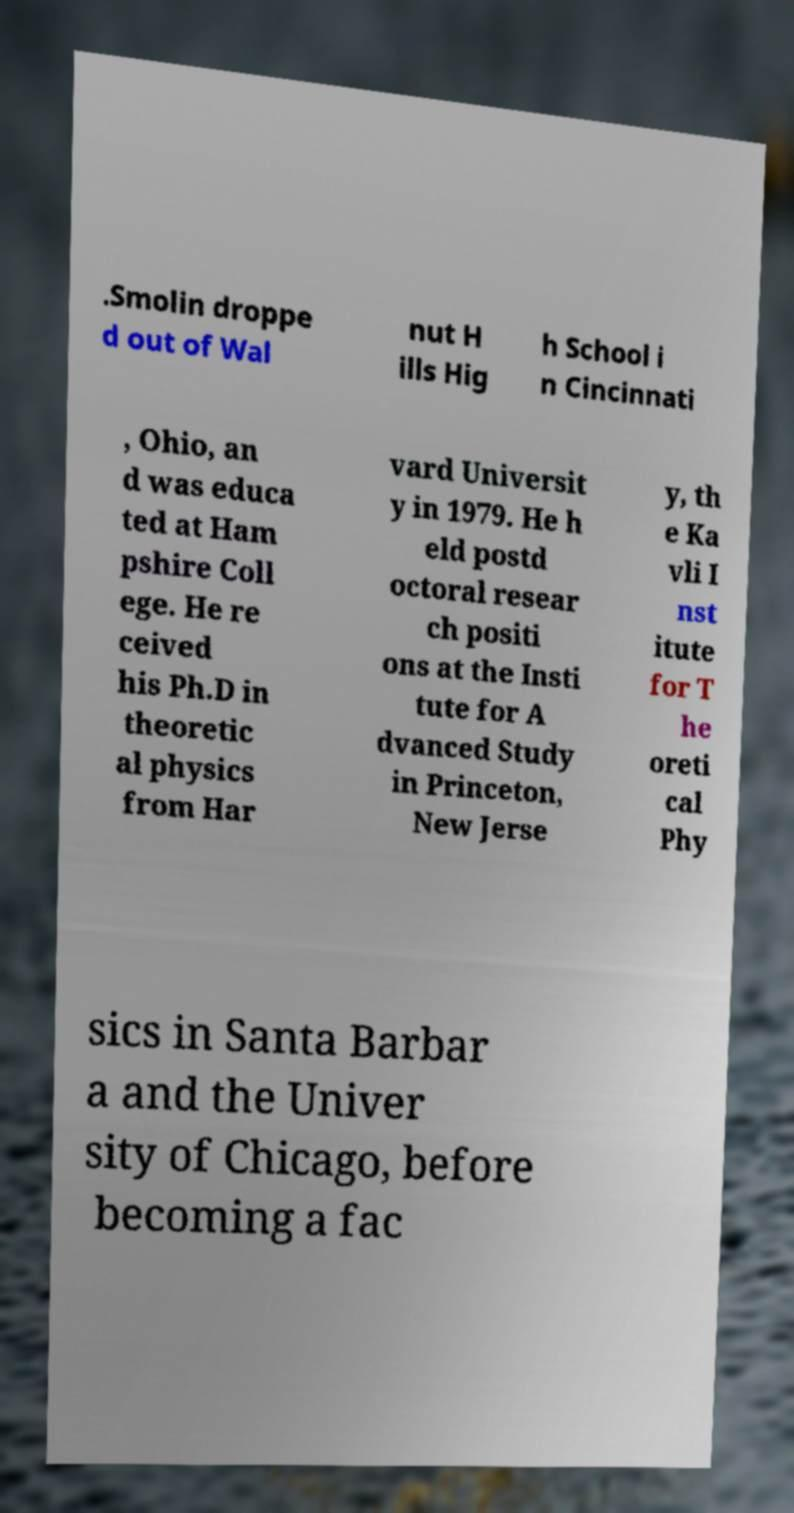Can you read and provide the text displayed in the image?This photo seems to have some interesting text. Can you extract and type it out for me? .Smolin droppe d out of Wal nut H ills Hig h School i n Cincinnati , Ohio, an d was educa ted at Ham pshire Coll ege. He re ceived his Ph.D in theoretic al physics from Har vard Universit y in 1979. He h eld postd octoral resear ch positi ons at the Insti tute for A dvanced Study in Princeton, New Jerse y, th e Ka vli I nst itute for T he oreti cal Phy sics in Santa Barbar a and the Univer sity of Chicago, before becoming a fac 